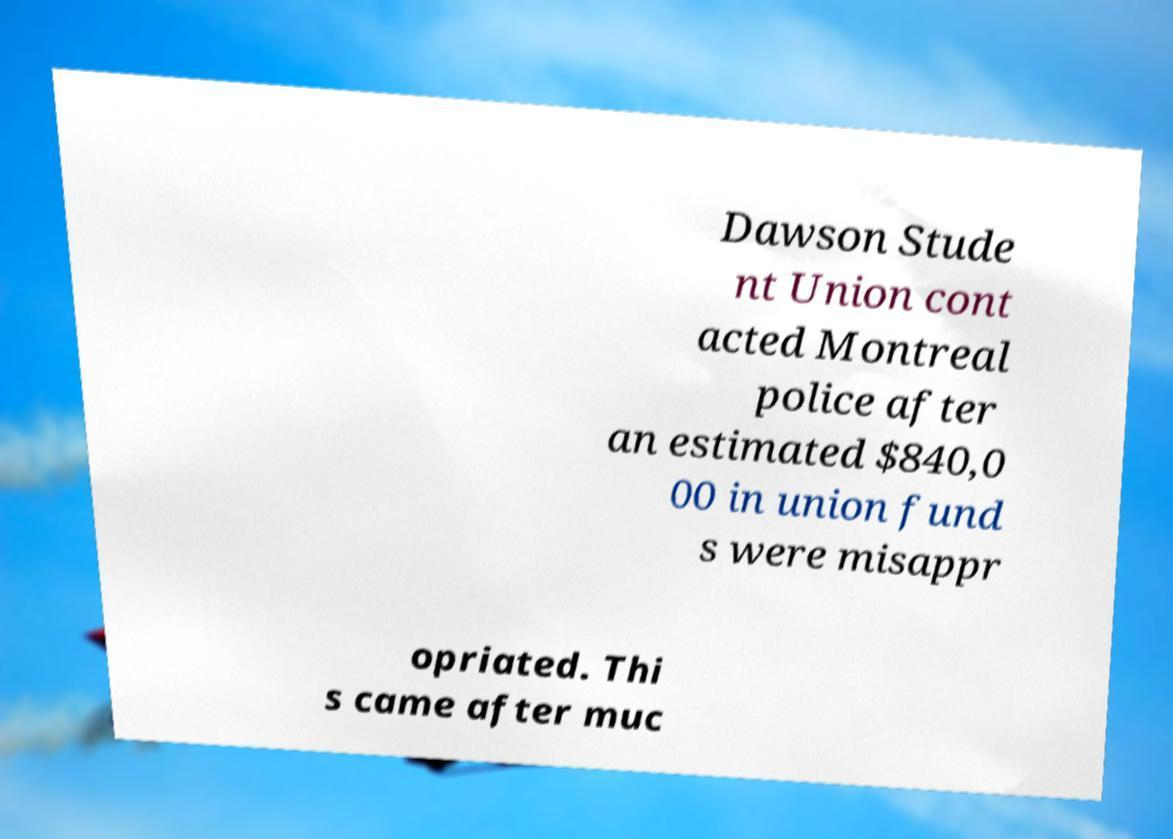What messages or text are displayed in this image? I need them in a readable, typed format. Dawson Stude nt Union cont acted Montreal police after an estimated $840,0 00 in union fund s were misappr opriated. Thi s came after muc 